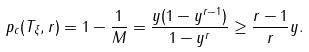Convert formula to latex. <formula><loc_0><loc_0><loc_500><loc_500>p _ { c } ( T _ { \xi } , r ) = 1 - \frac { 1 } { M } = \frac { y ( 1 - y ^ { r - 1 } ) } { 1 - y ^ { r } } \geq \frac { r - 1 } { r } y .</formula> 